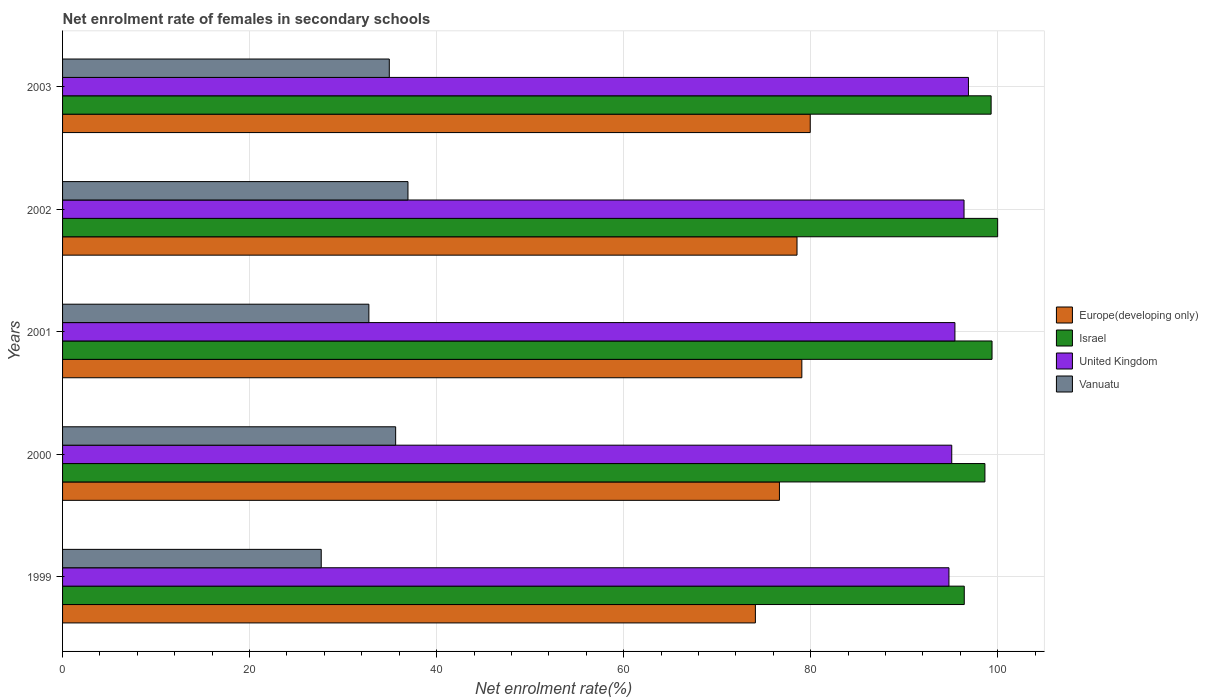Are the number of bars per tick equal to the number of legend labels?
Your answer should be compact. Yes. Are the number of bars on each tick of the Y-axis equal?
Keep it short and to the point. Yes. What is the label of the 1st group of bars from the top?
Give a very brief answer. 2003. In how many cases, is the number of bars for a given year not equal to the number of legend labels?
Your answer should be very brief. 0. What is the net enrolment rate of females in secondary schools in Israel in 2001?
Your answer should be compact. 99.4. Across all years, what is the maximum net enrolment rate of females in secondary schools in Vanuatu?
Give a very brief answer. 36.94. Across all years, what is the minimum net enrolment rate of females in secondary schools in United Kingdom?
Offer a terse response. 94.79. In which year was the net enrolment rate of females in secondary schools in Israel maximum?
Offer a very short reply. 2002. In which year was the net enrolment rate of females in secondary schools in Vanuatu minimum?
Keep it short and to the point. 1999. What is the total net enrolment rate of females in secondary schools in Israel in the graph?
Keep it short and to the point. 493.77. What is the difference between the net enrolment rate of females in secondary schools in Europe(developing only) in 2001 and that in 2003?
Provide a short and direct response. -0.9. What is the difference between the net enrolment rate of females in secondary schools in Israel in 1999 and the net enrolment rate of females in secondary schools in United Kingdom in 2002?
Give a very brief answer. 0.03. What is the average net enrolment rate of females in secondary schools in Europe(developing only) per year?
Your answer should be compact. 77.66. In the year 2001, what is the difference between the net enrolment rate of females in secondary schools in United Kingdom and net enrolment rate of females in secondary schools in Israel?
Keep it short and to the point. -3.97. In how many years, is the net enrolment rate of females in secondary schools in Europe(developing only) greater than 76 %?
Make the answer very short. 4. What is the ratio of the net enrolment rate of females in secondary schools in Israel in 2000 to that in 2003?
Your answer should be compact. 0.99. Is the difference between the net enrolment rate of females in secondary schools in United Kingdom in 2000 and 2001 greater than the difference between the net enrolment rate of females in secondary schools in Israel in 2000 and 2001?
Offer a very short reply. Yes. What is the difference between the highest and the second highest net enrolment rate of females in secondary schools in Israel?
Keep it short and to the point. 0.6. What is the difference between the highest and the lowest net enrolment rate of females in secondary schools in Vanuatu?
Offer a terse response. 9.28. What does the 1st bar from the top in 2003 represents?
Your answer should be compact. Vanuatu. What does the 1st bar from the bottom in 2003 represents?
Provide a short and direct response. Europe(developing only). Is it the case that in every year, the sum of the net enrolment rate of females in secondary schools in Israel and net enrolment rate of females in secondary schools in United Kingdom is greater than the net enrolment rate of females in secondary schools in Vanuatu?
Provide a short and direct response. Yes. Are all the bars in the graph horizontal?
Ensure brevity in your answer.  Yes. What is the difference between two consecutive major ticks on the X-axis?
Provide a succinct answer. 20. Are the values on the major ticks of X-axis written in scientific E-notation?
Offer a terse response. No. Does the graph contain any zero values?
Provide a succinct answer. No. How many legend labels are there?
Offer a very short reply. 4. How are the legend labels stacked?
Your answer should be very brief. Vertical. What is the title of the graph?
Ensure brevity in your answer.  Net enrolment rate of females in secondary schools. What is the label or title of the X-axis?
Offer a terse response. Net enrolment rate(%). What is the label or title of the Y-axis?
Offer a terse response. Years. What is the Net enrolment rate(%) in Europe(developing only) in 1999?
Your answer should be compact. 74.09. What is the Net enrolment rate(%) of Israel in 1999?
Your response must be concise. 96.43. What is the Net enrolment rate(%) of United Kingdom in 1999?
Your answer should be compact. 94.79. What is the Net enrolment rate(%) in Vanuatu in 1999?
Your answer should be very brief. 27.66. What is the Net enrolment rate(%) in Europe(developing only) in 2000?
Keep it short and to the point. 76.66. What is the Net enrolment rate(%) in Israel in 2000?
Keep it short and to the point. 98.64. What is the Net enrolment rate(%) of United Kingdom in 2000?
Keep it short and to the point. 95.09. What is the Net enrolment rate(%) of Vanuatu in 2000?
Your answer should be very brief. 35.62. What is the Net enrolment rate(%) in Europe(developing only) in 2001?
Your answer should be compact. 79.06. What is the Net enrolment rate(%) of Israel in 2001?
Offer a very short reply. 99.4. What is the Net enrolment rate(%) in United Kingdom in 2001?
Provide a short and direct response. 95.43. What is the Net enrolment rate(%) in Vanuatu in 2001?
Keep it short and to the point. 32.76. What is the Net enrolment rate(%) in Europe(developing only) in 2002?
Offer a very short reply. 78.54. What is the Net enrolment rate(%) of United Kingdom in 2002?
Provide a short and direct response. 96.4. What is the Net enrolment rate(%) of Vanuatu in 2002?
Provide a succinct answer. 36.94. What is the Net enrolment rate(%) of Europe(developing only) in 2003?
Offer a terse response. 79.96. What is the Net enrolment rate(%) in Israel in 2003?
Make the answer very short. 99.3. What is the Net enrolment rate(%) in United Kingdom in 2003?
Give a very brief answer. 96.88. What is the Net enrolment rate(%) in Vanuatu in 2003?
Your response must be concise. 34.94. Across all years, what is the maximum Net enrolment rate(%) of Europe(developing only)?
Provide a short and direct response. 79.96. Across all years, what is the maximum Net enrolment rate(%) of United Kingdom?
Keep it short and to the point. 96.88. Across all years, what is the maximum Net enrolment rate(%) of Vanuatu?
Make the answer very short. 36.94. Across all years, what is the minimum Net enrolment rate(%) of Europe(developing only)?
Offer a terse response. 74.09. Across all years, what is the minimum Net enrolment rate(%) in Israel?
Offer a terse response. 96.43. Across all years, what is the minimum Net enrolment rate(%) in United Kingdom?
Give a very brief answer. 94.79. Across all years, what is the minimum Net enrolment rate(%) of Vanuatu?
Keep it short and to the point. 27.66. What is the total Net enrolment rate(%) in Europe(developing only) in the graph?
Offer a very short reply. 388.31. What is the total Net enrolment rate(%) of Israel in the graph?
Offer a terse response. 493.77. What is the total Net enrolment rate(%) in United Kingdom in the graph?
Your answer should be compact. 478.59. What is the total Net enrolment rate(%) of Vanuatu in the graph?
Keep it short and to the point. 167.92. What is the difference between the Net enrolment rate(%) in Europe(developing only) in 1999 and that in 2000?
Your answer should be compact. -2.57. What is the difference between the Net enrolment rate(%) in Israel in 1999 and that in 2000?
Your answer should be compact. -2.21. What is the difference between the Net enrolment rate(%) of United Kingdom in 1999 and that in 2000?
Keep it short and to the point. -0.3. What is the difference between the Net enrolment rate(%) in Vanuatu in 1999 and that in 2000?
Provide a short and direct response. -7.96. What is the difference between the Net enrolment rate(%) of Europe(developing only) in 1999 and that in 2001?
Ensure brevity in your answer.  -4.97. What is the difference between the Net enrolment rate(%) of Israel in 1999 and that in 2001?
Offer a very short reply. -2.97. What is the difference between the Net enrolment rate(%) in United Kingdom in 1999 and that in 2001?
Offer a very short reply. -0.64. What is the difference between the Net enrolment rate(%) of Vanuatu in 1999 and that in 2001?
Make the answer very short. -5.1. What is the difference between the Net enrolment rate(%) of Europe(developing only) in 1999 and that in 2002?
Provide a short and direct response. -4.45. What is the difference between the Net enrolment rate(%) of Israel in 1999 and that in 2002?
Your response must be concise. -3.57. What is the difference between the Net enrolment rate(%) in United Kingdom in 1999 and that in 2002?
Make the answer very short. -1.61. What is the difference between the Net enrolment rate(%) of Vanuatu in 1999 and that in 2002?
Make the answer very short. -9.28. What is the difference between the Net enrolment rate(%) in Europe(developing only) in 1999 and that in 2003?
Your response must be concise. -5.87. What is the difference between the Net enrolment rate(%) in Israel in 1999 and that in 2003?
Provide a succinct answer. -2.87. What is the difference between the Net enrolment rate(%) in United Kingdom in 1999 and that in 2003?
Offer a terse response. -2.09. What is the difference between the Net enrolment rate(%) of Vanuatu in 1999 and that in 2003?
Ensure brevity in your answer.  -7.28. What is the difference between the Net enrolment rate(%) in Europe(developing only) in 2000 and that in 2001?
Make the answer very short. -2.4. What is the difference between the Net enrolment rate(%) in Israel in 2000 and that in 2001?
Make the answer very short. -0.76. What is the difference between the Net enrolment rate(%) of United Kingdom in 2000 and that in 2001?
Give a very brief answer. -0.34. What is the difference between the Net enrolment rate(%) of Vanuatu in 2000 and that in 2001?
Offer a very short reply. 2.86. What is the difference between the Net enrolment rate(%) in Europe(developing only) in 2000 and that in 2002?
Your answer should be very brief. -1.88. What is the difference between the Net enrolment rate(%) of Israel in 2000 and that in 2002?
Make the answer very short. -1.36. What is the difference between the Net enrolment rate(%) of United Kingdom in 2000 and that in 2002?
Your response must be concise. -1.31. What is the difference between the Net enrolment rate(%) of Vanuatu in 2000 and that in 2002?
Make the answer very short. -1.32. What is the difference between the Net enrolment rate(%) of Europe(developing only) in 2000 and that in 2003?
Offer a very short reply. -3.29. What is the difference between the Net enrolment rate(%) of Israel in 2000 and that in 2003?
Your response must be concise. -0.66. What is the difference between the Net enrolment rate(%) in United Kingdom in 2000 and that in 2003?
Your answer should be very brief. -1.79. What is the difference between the Net enrolment rate(%) in Vanuatu in 2000 and that in 2003?
Ensure brevity in your answer.  0.68. What is the difference between the Net enrolment rate(%) of Europe(developing only) in 2001 and that in 2002?
Give a very brief answer. 0.52. What is the difference between the Net enrolment rate(%) in Israel in 2001 and that in 2002?
Offer a very short reply. -0.6. What is the difference between the Net enrolment rate(%) of United Kingdom in 2001 and that in 2002?
Your response must be concise. -0.97. What is the difference between the Net enrolment rate(%) of Vanuatu in 2001 and that in 2002?
Your response must be concise. -4.18. What is the difference between the Net enrolment rate(%) in Europe(developing only) in 2001 and that in 2003?
Your response must be concise. -0.9. What is the difference between the Net enrolment rate(%) in Israel in 2001 and that in 2003?
Keep it short and to the point. 0.1. What is the difference between the Net enrolment rate(%) of United Kingdom in 2001 and that in 2003?
Make the answer very short. -1.45. What is the difference between the Net enrolment rate(%) in Vanuatu in 2001 and that in 2003?
Make the answer very short. -2.18. What is the difference between the Net enrolment rate(%) in Europe(developing only) in 2002 and that in 2003?
Make the answer very short. -1.41. What is the difference between the Net enrolment rate(%) of Israel in 2002 and that in 2003?
Ensure brevity in your answer.  0.7. What is the difference between the Net enrolment rate(%) of United Kingdom in 2002 and that in 2003?
Your answer should be compact. -0.47. What is the difference between the Net enrolment rate(%) in Vanuatu in 2002 and that in 2003?
Ensure brevity in your answer.  2. What is the difference between the Net enrolment rate(%) of Europe(developing only) in 1999 and the Net enrolment rate(%) of Israel in 2000?
Your response must be concise. -24.55. What is the difference between the Net enrolment rate(%) of Europe(developing only) in 1999 and the Net enrolment rate(%) of United Kingdom in 2000?
Provide a succinct answer. -21. What is the difference between the Net enrolment rate(%) in Europe(developing only) in 1999 and the Net enrolment rate(%) in Vanuatu in 2000?
Provide a succinct answer. 38.47. What is the difference between the Net enrolment rate(%) of Israel in 1999 and the Net enrolment rate(%) of United Kingdom in 2000?
Keep it short and to the point. 1.34. What is the difference between the Net enrolment rate(%) in Israel in 1999 and the Net enrolment rate(%) in Vanuatu in 2000?
Your answer should be very brief. 60.81. What is the difference between the Net enrolment rate(%) of United Kingdom in 1999 and the Net enrolment rate(%) of Vanuatu in 2000?
Ensure brevity in your answer.  59.17. What is the difference between the Net enrolment rate(%) of Europe(developing only) in 1999 and the Net enrolment rate(%) of Israel in 2001?
Provide a succinct answer. -25.31. What is the difference between the Net enrolment rate(%) in Europe(developing only) in 1999 and the Net enrolment rate(%) in United Kingdom in 2001?
Your answer should be very brief. -21.34. What is the difference between the Net enrolment rate(%) in Europe(developing only) in 1999 and the Net enrolment rate(%) in Vanuatu in 2001?
Give a very brief answer. 41.33. What is the difference between the Net enrolment rate(%) in Israel in 1999 and the Net enrolment rate(%) in Vanuatu in 2001?
Provide a short and direct response. 63.67. What is the difference between the Net enrolment rate(%) in United Kingdom in 1999 and the Net enrolment rate(%) in Vanuatu in 2001?
Your answer should be compact. 62.03. What is the difference between the Net enrolment rate(%) of Europe(developing only) in 1999 and the Net enrolment rate(%) of Israel in 2002?
Make the answer very short. -25.91. What is the difference between the Net enrolment rate(%) in Europe(developing only) in 1999 and the Net enrolment rate(%) in United Kingdom in 2002?
Provide a short and direct response. -22.31. What is the difference between the Net enrolment rate(%) of Europe(developing only) in 1999 and the Net enrolment rate(%) of Vanuatu in 2002?
Your answer should be very brief. 37.15. What is the difference between the Net enrolment rate(%) of Israel in 1999 and the Net enrolment rate(%) of United Kingdom in 2002?
Give a very brief answer. 0.03. What is the difference between the Net enrolment rate(%) of Israel in 1999 and the Net enrolment rate(%) of Vanuatu in 2002?
Your answer should be compact. 59.49. What is the difference between the Net enrolment rate(%) of United Kingdom in 1999 and the Net enrolment rate(%) of Vanuatu in 2002?
Offer a terse response. 57.85. What is the difference between the Net enrolment rate(%) in Europe(developing only) in 1999 and the Net enrolment rate(%) in Israel in 2003?
Ensure brevity in your answer.  -25.21. What is the difference between the Net enrolment rate(%) in Europe(developing only) in 1999 and the Net enrolment rate(%) in United Kingdom in 2003?
Ensure brevity in your answer.  -22.79. What is the difference between the Net enrolment rate(%) of Europe(developing only) in 1999 and the Net enrolment rate(%) of Vanuatu in 2003?
Offer a terse response. 39.15. What is the difference between the Net enrolment rate(%) in Israel in 1999 and the Net enrolment rate(%) in United Kingdom in 2003?
Provide a short and direct response. -0.45. What is the difference between the Net enrolment rate(%) of Israel in 1999 and the Net enrolment rate(%) of Vanuatu in 2003?
Your answer should be very brief. 61.49. What is the difference between the Net enrolment rate(%) in United Kingdom in 1999 and the Net enrolment rate(%) in Vanuatu in 2003?
Provide a short and direct response. 59.85. What is the difference between the Net enrolment rate(%) in Europe(developing only) in 2000 and the Net enrolment rate(%) in Israel in 2001?
Ensure brevity in your answer.  -22.74. What is the difference between the Net enrolment rate(%) in Europe(developing only) in 2000 and the Net enrolment rate(%) in United Kingdom in 2001?
Offer a terse response. -18.77. What is the difference between the Net enrolment rate(%) of Europe(developing only) in 2000 and the Net enrolment rate(%) of Vanuatu in 2001?
Your response must be concise. 43.9. What is the difference between the Net enrolment rate(%) of Israel in 2000 and the Net enrolment rate(%) of United Kingdom in 2001?
Offer a terse response. 3.21. What is the difference between the Net enrolment rate(%) in Israel in 2000 and the Net enrolment rate(%) in Vanuatu in 2001?
Your response must be concise. 65.88. What is the difference between the Net enrolment rate(%) in United Kingdom in 2000 and the Net enrolment rate(%) in Vanuatu in 2001?
Make the answer very short. 62.33. What is the difference between the Net enrolment rate(%) of Europe(developing only) in 2000 and the Net enrolment rate(%) of Israel in 2002?
Give a very brief answer. -23.34. What is the difference between the Net enrolment rate(%) of Europe(developing only) in 2000 and the Net enrolment rate(%) of United Kingdom in 2002?
Your answer should be compact. -19.74. What is the difference between the Net enrolment rate(%) of Europe(developing only) in 2000 and the Net enrolment rate(%) of Vanuatu in 2002?
Make the answer very short. 39.72. What is the difference between the Net enrolment rate(%) of Israel in 2000 and the Net enrolment rate(%) of United Kingdom in 2002?
Your answer should be compact. 2.23. What is the difference between the Net enrolment rate(%) of Israel in 2000 and the Net enrolment rate(%) of Vanuatu in 2002?
Offer a very short reply. 61.7. What is the difference between the Net enrolment rate(%) in United Kingdom in 2000 and the Net enrolment rate(%) in Vanuatu in 2002?
Provide a short and direct response. 58.15. What is the difference between the Net enrolment rate(%) of Europe(developing only) in 2000 and the Net enrolment rate(%) of Israel in 2003?
Provide a short and direct response. -22.64. What is the difference between the Net enrolment rate(%) of Europe(developing only) in 2000 and the Net enrolment rate(%) of United Kingdom in 2003?
Provide a succinct answer. -20.21. What is the difference between the Net enrolment rate(%) of Europe(developing only) in 2000 and the Net enrolment rate(%) of Vanuatu in 2003?
Provide a short and direct response. 41.72. What is the difference between the Net enrolment rate(%) in Israel in 2000 and the Net enrolment rate(%) in United Kingdom in 2003?
Your answer should be compact. 1.76. What is the difference between the Net enrolment rate(%) in Israel in 2000 and the Net enrolment rate(%) in Vanuatu in 2003?
Ensure brevity in your answer.  63.7. What is the difference between the Net enrolment rate(%) in United Kingdom in 2000 and the Net enrolment rate(%) in Vanuatu in 2003?
Keep it short and to the point. 60.15. What is the difference between the Net enrolment rate(%) in Europe(developing only) in 2001 and the Net enrolment rate(%) in Israel in 2002?
Provide a succinct answer. -20.94. What is the difference between the Net enrolment rate(%) in Europe(developing only) in 2001 and the Net enrolment rate(%) in United Kingdom in 2002?
Offer a very short reply. -17.35. What is the difference between the Net enrolment rate(%) in Europe(developing only) in 2001 and the Net enrolment rate(%) in Vanuatu in 2002?
Your answer should be very brief. 42.12. What is the difference between the Net enrolment rate(%) in Israel in 2001 and the Net enrolment rate(%) in United Kingdom in 2002?
Your answer should be very brief. 2.99. What is the difference between the Net enrolment rate(%) in Israel in 2001 and the Net enrolment rate(%) in Vanuatu in 2002?
Your response must be concise. 62.46. What is the difference between the Net enrolment rate(%) in United Kingdom in 2001 and the Net enrolment rate(%) in Vanuatu in 2002?
Provide a succinct answer. 58.49. What is the difference between the Net enrolment rate(%) in Europe(developing only) in 2001 and the Net enrolment rate(%) in Israel in 2003?
Your answer should be very brief. -20.24. What is the difference between the Net enrolment rate(%) in Europe(developing only) in 2001 and the Net enrolment rate(%) in United Kingdom in 2003?
Your answer should be compact. -17.82. What is the difference between the Net enrolment rate(%) of Europe(developing only) in 2001 and the Net enrolment rate(%) of Vanuatu in 2003?
Offer a very short reply. 44.12. What is the difference between the Net enrolment rate(%) in Israel in 2001 and the Net enrolment rate(%) in United Kingdom in 2003?
Provide a short and direct response. 2.52. What is the difference between the Net enrolment rate(%) in Israel in 2001 and the Net enrolment rate(%) in Vanuatu in 2003?
Make the answer very short. 64.46. What is the difference between the Net enrolment rate(%) of United Kingdom in 2001 and the Net enrolment rate(%) of Vanuatu in 2003?
Your answer should be compact. 60.49. What is the difference between the Net enrolment rate(%) of Europe(developing only) in 2002 and the Net enrolment rate(%) of Israel in 2003?
Keep it short and to the point. -20.76. What is the difference between the Net enrolment rate(%) in Europe(developing only) in 2002 and the Net enrolment rate(%) in United Kingdom in 2003?
Provide a short and direct response. -18.33. What is the difference between the Net enrolment rate(%) of Europe(developing only) in 2002 and the Net enrolment rate(%) of Vanuatu in 2003?
Provide a succinct answer. 43.6. What is the difference between the Net enrolment rate(%) of Israel in 2002 and the Net enrolment rate(%) of United Kingdom in 2003?
Provide a succinct answer. 3.12. What is the difference between the Net enrolment rate(%) in Israel in 2002 and the Net enrolment rate(%) in Vanuatu in 2003?
Your answer should be compact. 65.06. What is the difference between the Net enrolment rate(%) in United Kingdom in 2002 and the Net enrolment rate(%) in Vanuatu in 2003?
Give a very brief answer. 61.46. What is the average Net enrolment rate(%) of Europe(developing only) per year?
Your answer should be very brief. 77.66. What is the average Net enrolment rate(%) in Israel per year?
Provide a short and direct response. 98.75. What is the average Net enrolment rate(%) in United Kingdom per year?
Offer a terse response. 95.72. What is the average Net enrolment rate(%) in Vanuatu per year?
Offer a terse response. 33.58. In the year 1999, what is the difference between the Net enrolment rate(%) in Europe(developing only) and Net enrolment rate(%) in Israel?
Provide a succinct answer. -22.34. In the year 1999, what is the difference between the Net enrolment rate(%) of Europe(developing only) and Net enrolment rate(%) of United Kingdom?
Keep it short and to the point. -20.7. In the year 1999, what is the difference between the Net enrolment rate(%) in Europe(developing only) and Net enrolment rate(%) in Vanuatu?
Your response must be concise. 46.43. In the year 1999, what is the difference between the Net enrolment rate(%) of Israel and Net enrolment rate(%) of United Kingdom?
Your response must be concise. 1.64. In the year 1999, what is the difference between the Net enrolment rate(%) of Israel and Net enrolment rate(%) of Vanuatu?
Keep it short and to the point. 68.77. In the year 1999, what is the difference between the Net enrolment rate(%) in United Kingdom and Net enrolment rate(%) in Vanuatu?
Your answer should be compact. 67.13. In the year 2000, what is the difference between the Net enrolment rate(%) of Europe(developing only) and Net enrolment rate(%) of Israel?
Make the answer very short. -21.98. In the year 2000, what is the difference between the Net enrolment rate(%) of Europe(developing only) and Net enrolment rate(%) of United Kingdom?
Your answer should be compact. -18.43. In the year 2000, what is the difference between the Net enrolment rate(%) in Europe(developing only) and Net enrolment rate(%) in Vanuatu?
Offer a very short reply. 41.04. In the year 2000, what is the difference between the Net enrolment rate(%) in Israel and Net enrolment rate(%) in United Kingdom?
Offer a very short reply. 3.55. In the year 2000, what is the difference between the Net enrolment rate(%) in Israel and Net enrolment rate(%) in Vanuatu?
Provide a short and direct response. 63.02. In the year 2000, what is the difference between the Net enrolment rate(%) of United Kingdom and Net enrolment rate(%) of Vanuatu?
Provide a short and direct response. 59.47. In the year 2001, what is the difference between the Net enrolment rate(%) in Europe(developing only) and Net enrolment rate(%) in Israel?
Offer a very short reply. -20.34. In the year 2001, what is the difference between the Net enrolment rate(%) in Europe(developing only) and Net enrolment rate(%) in United Kingdom?
Provide a succinct answer. -16.37. In the year 2001, what is the difference between the Net enrolment rate(%) of Europe(developing only) and Net enrolment rate(%) of Vanuatu?
Your response must be concise. 46.3. In the year 2001, what is the difference between the Net enrolment rate(%) of Israel and Net enrolment rate(%) of United Kingdom?
Provide a short and direct response. 3.97. In the year 2001, what is the difference between the Net enrolment rate(%) of Israel and Net enrolment rate(%) of Vanuatu?
Your response must be concise. 66.64. In the year 2001, what is the difference between the Net enrolment rate(%) of United Kingdom and Net enrolment rate(%) of Vanuatu?
Provide a short and direct response. 62.67. In the year 2002, what is the difference between the Net enrolment rate(%) in Europe(developing only) and Net enrolment rate(%) in Israel?
Make the answer very short. -21.46. In the year 2002, what is the difference between the Net enrolment rate(%) of Europe(developing only) and Net enrolment rate(%) of United Kingdom?
Make the answer very short. -17.86. In the year 2002, what is the difference between the Net enrolment rate(%) in Europe(developing only) and Net enrolment rate(%) in Vanuatu?
Your response must be concise. 41.6. In the year 2002, what is the difference between the Net enrolment rate(%) in Israel and Net enrolment rate(%) in United Kingdom?
Provide a short and direct response. 3.6. In the year 2002, what is the difference between the Net enrolment rate(%) of Israel and Net enrolment rate(%) of Vanuatu?
Offer a terse response. 63.06. In the year 2002, what is the difference between the Net enrolment rate(%) of United Kingdom and Net enrolment rate(%) of Vanuatu?
Make the answer very short. 59.47. In the year 2003, what is the difference between the Net enrolment rate(%) in Europe(developing only) and Net enrolment rate(%) in Israel?
Make the answer very short. -19.35. In the year 2003, what is the difference between the Net enrolment rate(%) of Europe(developing only) and Net enrolment rate(%) of United Kingdom?
Keep it short and to the point. -16.92. In the year 2003, what is the difference between the Net enrolment rate(%) in Europe(developing only) and Net enrolment rate(%) in Vanuatu?
Make the answer very short. 45.02. In the year 2003, what is the difference between the Net enrolment rate(%) in Israel and Net enrolment rate(%) in United Kingdom?
Provide a short and direct response. 2.42. In the year 2003, what is the difference between the Net enrolment rate(%) of Israel and Net enrolment rate(%) of Vanuatu?
Give a very brief answer. 64.36. In the year 2003, what is the difference between the Net enrolment rate(%) of United Kingdom and Net enrolment rate(%) of Vanuatu?
Offer a terse response. 61.94. What is the ratio of the Net enrolment rate(%) of Europe(developing only) in 1999 to that in 2000?
Give a very brief answer. 0.97. What is the ratio of the Net enrolment rate(%) of Israel in 1999 to that in 2000?
Your response must be concise. 0.98. What is the ratio of the Net enrolment rate(%) in Vanuatu in 1999 to that in 2000?
Your response must be concise. 0.78. What is the ratio of the Net enrolment rate(%) of Europe(developing only) in 1999 to that in 2001?
Ensure brevity in your answer.  0.94. What is the ratio of the Net enrolment rate(%) in Israel in 1999 to that in 2001?
Offer a terse response. 0.97. What is the ratio of the Net enrolment rate(%) in Vanuatu in 1999 to that in 2001?
Your answer should be very brief. 0.84. What is the ratio of the Net enrolment rate(%) in Europe(developing only) in 1999 to that in 2002?
Offer a terse response. 0.94. What is the ratio of the Net enrolment rate(%) of Israel in 1999 to that in 2002?
Ensure brevity in your answer.  0.96. What is the ratio of the Net enrolment rate(%) of United Kingdom in 1999 to that in 2002?
Ensure brevity in your answer.  0.98. What is the ratio of the Net enrolment rate(%) of Vanuatu in 1999 to that in 2002?
Offer a very short reply. 0.75. What is the ratio of the Net enrolment rate(%) in Europe(developing only) in 1999 to that in 2003?
Offer a terse response. 0.93. What is the ratio of the Net enrolment rate(%) of Israel in 1999 to that in 2003?
Make the answer very short. 0.97. What is the ratio of the Net enrolment rate(%) of United Kingdom in 1999 to that in 2003?
Your answer should be very brief. 0.98. What is the ratio of the Net enrolment rate(%) in Vanuatu in 1999 to that in 2003?
Keep it short and to the point. 0.79. What is the ratio of the Net enrolment rate(%) in Europe(developing only) in 2000 to that in 2001?
Give a very brief answer. 0.97. What is the ratio of the Net enrolment rate(%) in Vanuatu in 2000 to that in 2001?
Provide a short and direct response. 1.09. What is the ratio of the Net enrolment rate(%) in Europe(developing only) in 2000 to that in 2002?
Ensure brevity in your answer.  0.98. What is the ratio of the Net enrolment rate(%) of Israel in 2000 to that in 2002?
Ensure brevity in your answer.  0.99. What is the ratio of the Net enrolment rate(%) in United Kingdom in 2000 to that in 2002?
Ensure brevity in your answer.  0.99. What is the ratio of the Net enrolment rate(%) of Vanuatu in 2000 to that in 2002?
Your answer should be compact. 0.96. What is the ratio of the Net enrolment rate(%) in Europe(developing only) in 2000 to that in 2003?
Offer a very short reply. 0.96. What is the ratio of the Net enrolment rate(%) in United Kingdom in 2000 to that in 2003?
Make the answer very short. 0.98. What is the ratio of the Net enrolment rate(%) of Vanuatu in 2000 to that in 2003?
Your answer should be very brief. 1.02. What is the ratio of the Net enrolment rate(%) of Europe(developing only) in 2001 to that in 2002?
Provide a succinct answer. 1.01. What is the ratio of the Net enrolment rate(%) in Israel in 2001 to that in 2002?
Offer a terse response. 0.99. What is the ratio of the Net enrolment rate(%) in Vanuatu in 2001 to that in 2002?
Provide a short and direct response. 0.89. What is the ratio of the Net enrolment rate(%) in United Kingdom in 2001 to that in 2003?
Provide a succinct answer. 0.99. What is the ratio of the Net enrolment rate(%) of Vanuatu in 2001 to that in 2003?
Your response must be concise. 0.94. What is the ratio of the Net enrolment rate(%) in Europe(developing only) in 2002 to that in 2003?
Offer a very short reply. 0.98. What is the ratio of the Net enrolment rate(%) in Vanuatu in 2002 to that in 2003?
Your answer should be compact. 1.06. What is the difference between the highest and the second highest Net enrolment rate(%) of Europe(developing only)?
Keep it short and to the point. 0.9. What is the difference between the highest and the second highest Net enrolment rate(%) in Israel?
Your answer should be compact. 0.6. What is the difference between the highest and the second highest Net enrolment rate(%) of United Kingdom?
Provide a short and direct response. 0.47. What is the difference between the highest and the second highest Net enrolment rate(%) of Vanuatu?
Offer a terse response. 1.32. What is the difference between the highest and the lowest Net enrolment rate(%) of Europe(developing only)?
Your response must be concise. 5.87. What is the difference between the highest and the lowest Net enrolment rate(%) in Israel?
Ensure brevity in your answer.  3.57. What is the difference between the highest and the lowest Net enrolment rate(%) of United Kingdom?
Ensure brevity in your answer.  2.09. What is the difference between the highest and the lowest Net enrolment rate(%) in Vanuatu?
Ensure brevity in your answer.  9.28. 